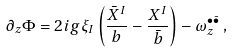<formula> <loc_0><loc_0><loc_500><loc_500>\partial _ { z } \Phi = 2 i g \xi _ { I } \left ( \frac { \bar { X } ^ { I } } b - \frac { X ^ { I } } { \bar { b } } \right ) - \omega ^ { \bullet \bar { \bullet } } _ { z } \, ,</formula> 